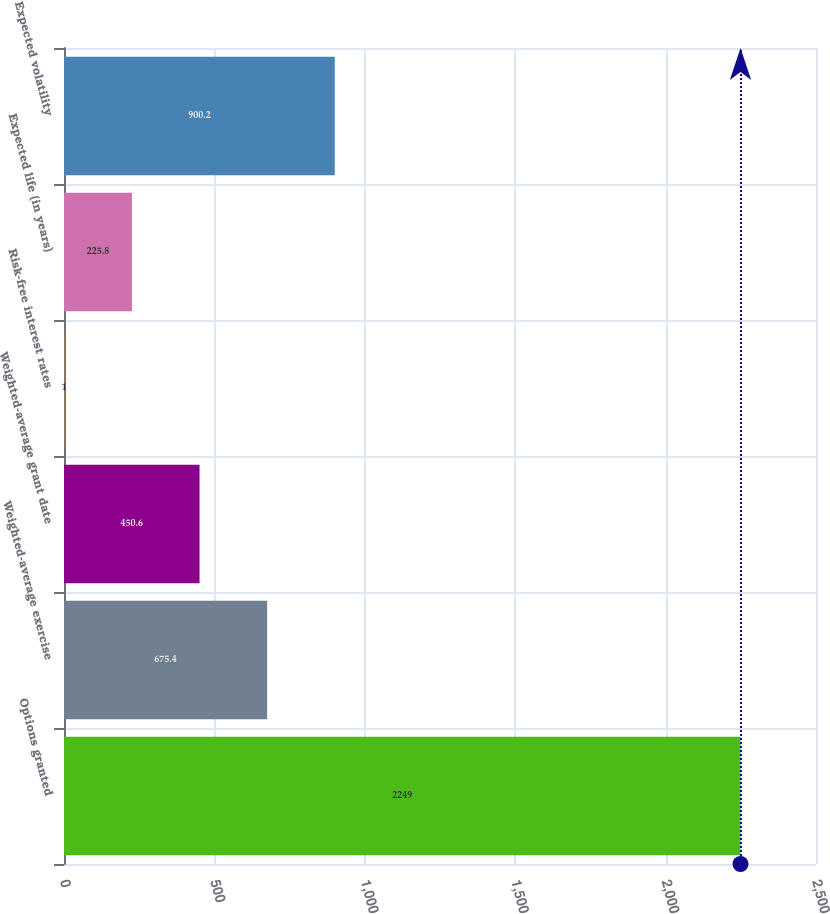Convert chart. <chart><loc_0><loc_0><loc_500><loc_500><bar_chart><fcel>Options granted<fcel>Weighted-average exercise<fcel>Weighted-average grant date<fcel>Risk-free interest rates<fcel>Expected life (in years)<fcel>Expected volatility<nl><fcel>2249<fcel>675.4<fcel>450.6<fcel>1<fcel>225.8<fcel>900.2<nl></chart> 